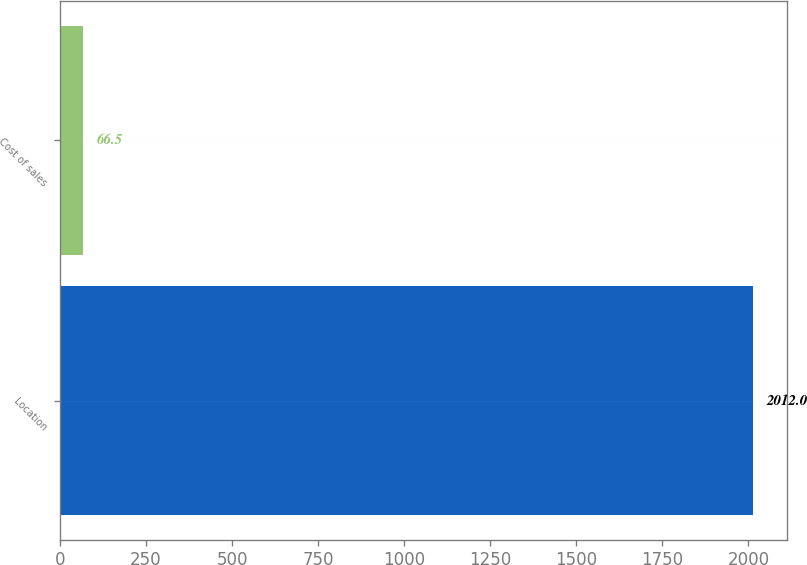Convert chart. <chart><loc_0><loc_0><loc_500><loc_500><bar_chart><fcel>Location<fcel>Cost of sales<nl><fcel>2012<fcel>66.5<nl></chart> 